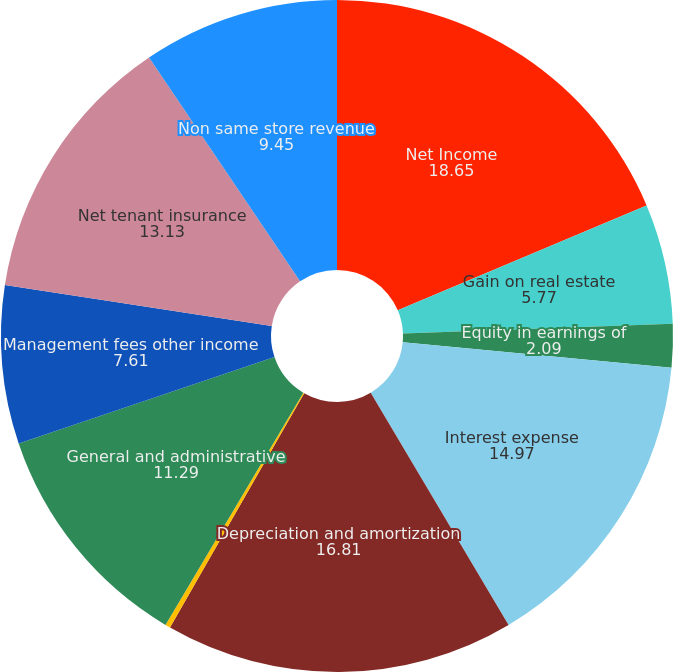<chart> <loc_0><loc_0><loc_500><loc_500><pie_chart><fcel>Net Income<fcel>Gain on real estate<fcel>Equity in earnings of<fcel>Interest expense<fcel>Depreciation and amortization<fcel>Income tax expense<fcel>General and administrative<fcel>Management fees other income<fcel>Net tenant insurance<fcel>Non same store revenue<nl><fcel>18.65%<fcel>5.77%<fcel>2.09%<fcel>14.97%<fcel>16.81%<fcel>0.25%<fcel>11.29%<fcel>7.61%<fcel>13.13%<fcel>9.45%<nl></chart> 